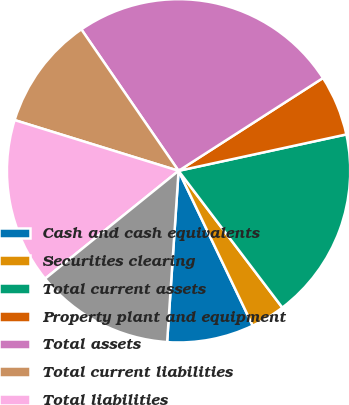Convert chart. <chart><loc_0><loc_0><loc_500><loc_500><pie_chart><fcel>Cash and cash equivalents<fcel>Securities clearing<fcel>Total current assets<fcel>Property plant and equipment<fcel>Total assets<fcel>Total current liabilities<fcel>Total liabilities<fcel>Total stockholders' equity<nl><fcel>8.17%<fcel>3.22%<fcel>18.07%<fcel>5.69%<fcel>25.49%<fcel>10.64%<fcel>15.59%<fcel>13.12%<nl></chart> 